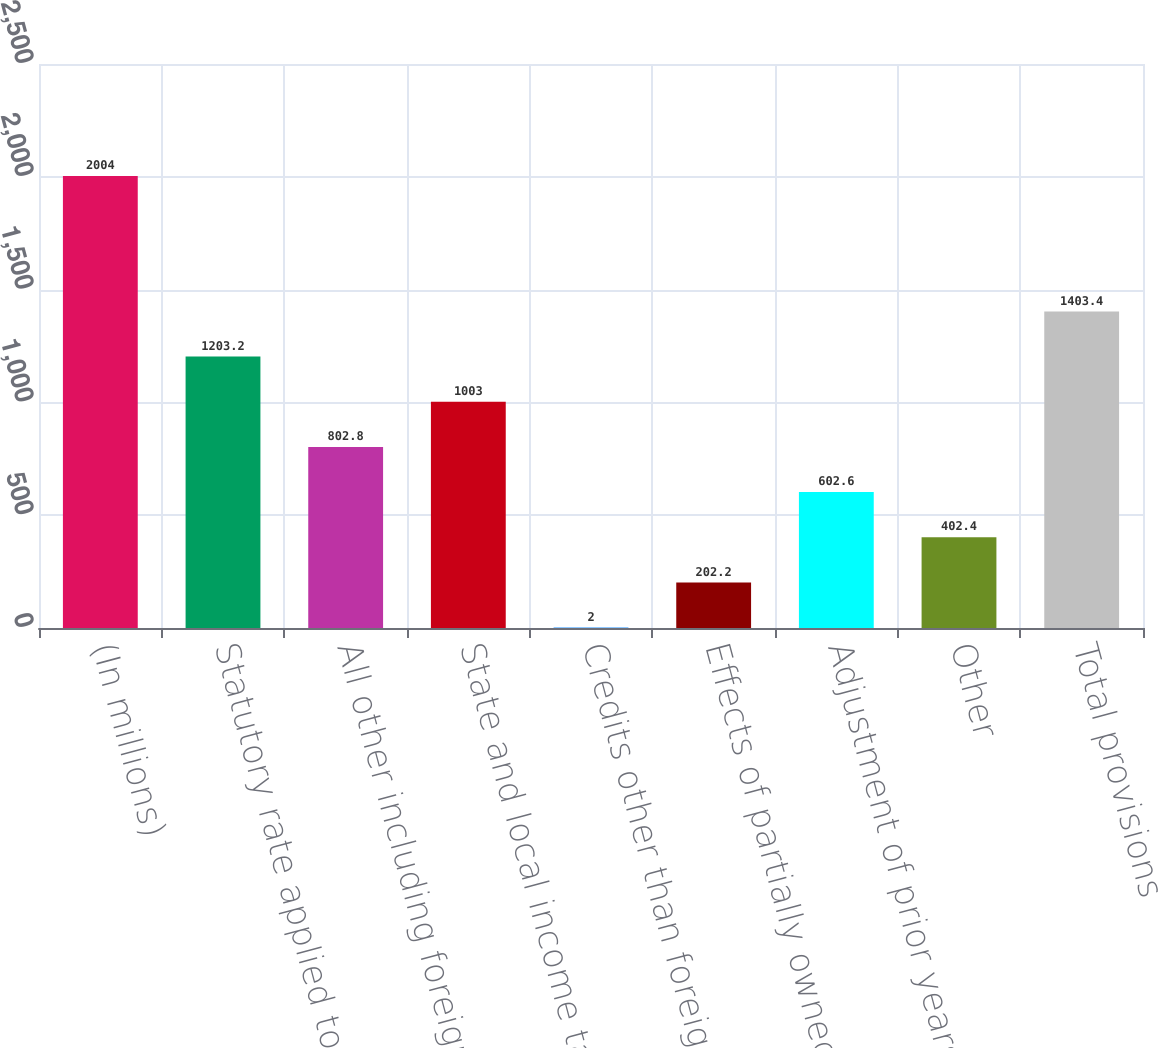Convert chart. <chart><loc_0><loc_0><loc_500><loc_500><bar_chart><fcel>(In millions)<fcel>Statutory rate applied to<fcel>All other including foreign<fcel>State and local income taxes<fcel>Credits other than foreign tax<fcel>Effects of partially owned<fcel>Adjustment of prior years'<fcel>Other<fcel>Total provisions<nl><fcel>2004<fcel>1203.2<fcel>802.8<fcel>1003<fcel>2<fcel>202.2<fcel>602.6<fcel>402.4<fcel>1403.4<nl></chart> 